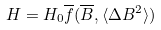<formula> <loc_0><loc_0><loc_500><loc_500>H = H _ { 0 } \overline { f } ( \overline { B } , \langle \Delta B ^ { 2 } \rangle )</formula> 